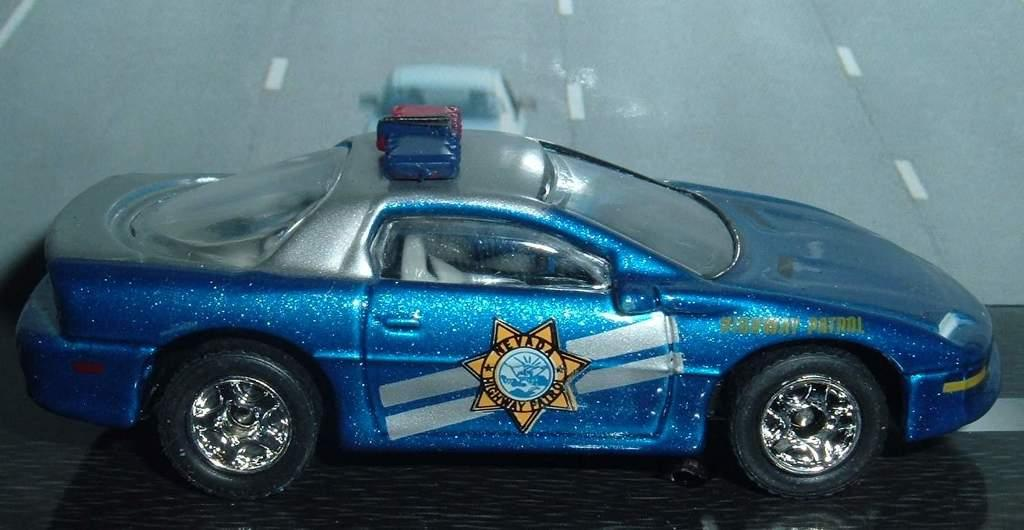What is the main subject in the middle of the picture? There is a blue toy car in the middle of the picture. What can be seen in the background of the image? There is a road visible in the background of the image. What is happening on the road in the background? A car is moving on the road in the background. What type of verse can be heard recited by the oven in the image? There is no oven or verse present in the image; it features a blue toy car and a road in the background. 